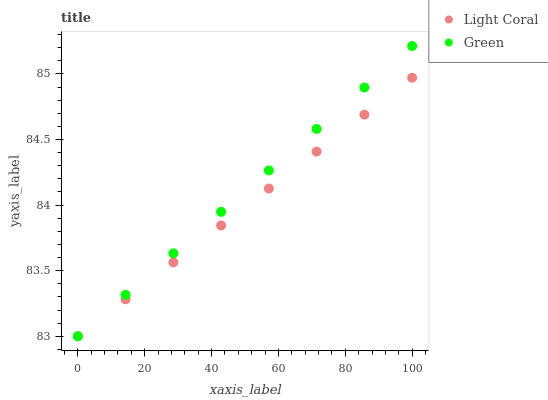Does Light Coral have the minimum area under the curve?
Answer yes or no. Yes. Does Green have the maximum area under the curve?
Answer yes or no. Yes. Does Green have the minimum area under the curve?
Answer yes or no. No. Is Light Coral the smoothest?
Answer yes or no. Yes. Is Green the roughest?
Answer yes or no. Yes. Is Green the smoothest?
Answer yes or no. No. Does Light Coral have the lowest value?
Answer yes or no. Yes. Does Green have the highest value?
Answer yes or no. Yes. Does Light Coral intersect Green?
Answer yes or no. Yes. Is Light Coral less than Green?
Answer yes or no. No. Is Light Coral greater than Green?
Answer yes or no. No. 